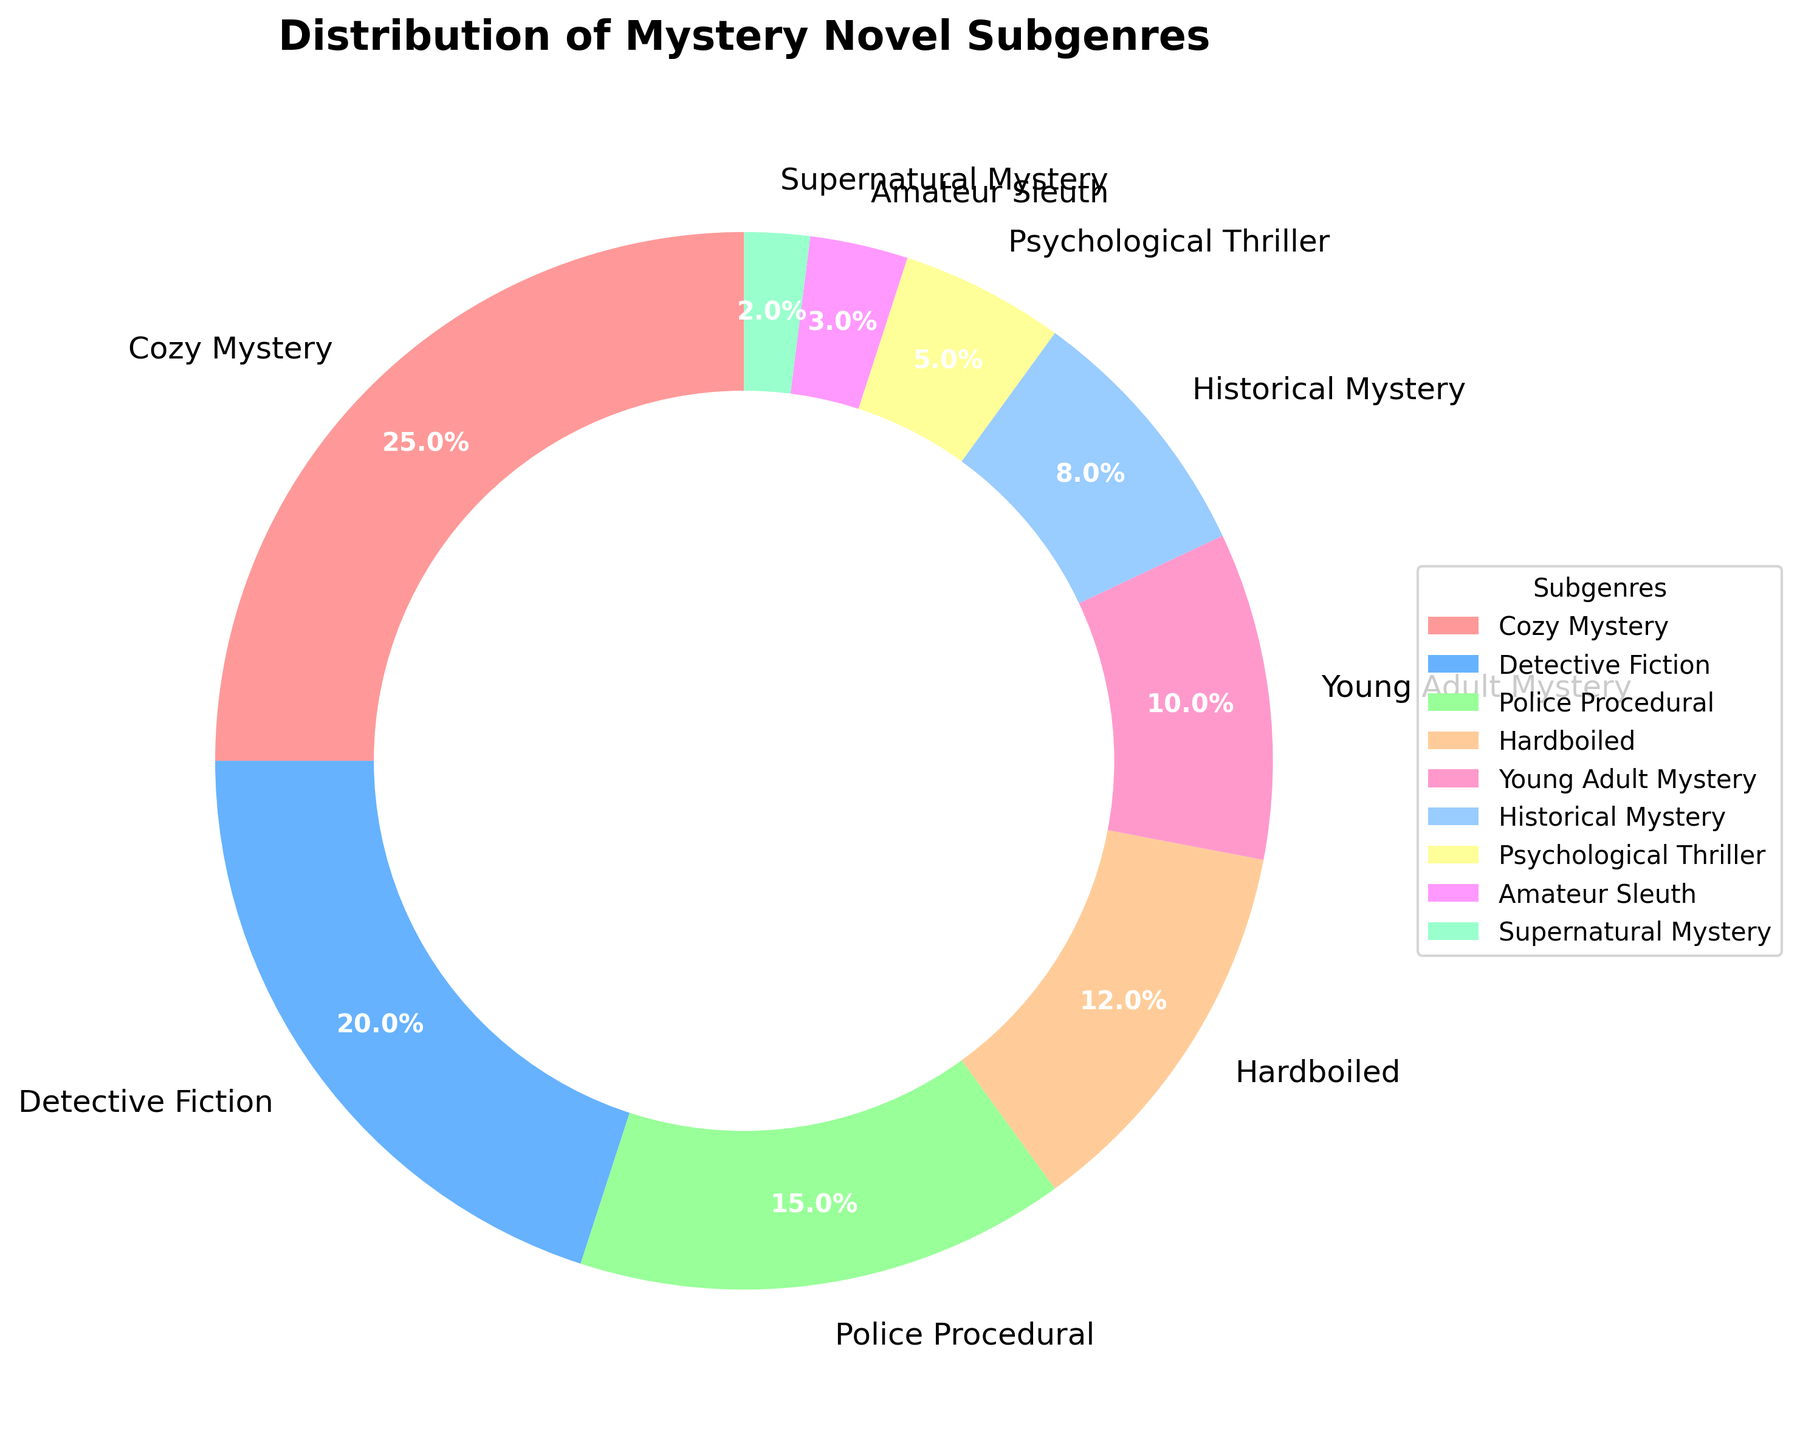Which subgenre occupies the largest portion of the pie chart? The largest portion of the pie chart is represented by the "Cozy Mystery" subgenre, which occupies 25% of the chart.
Answer: Cozy Mystery Which subgenre has the smallest percentage? The smallest portion of the chart is represented by the "Supernatural Mystery" subgenre, which occupies 2% of the chart.
Answer: Supernatural Mystery What is the combined percentage of the "Cozy Mystery" and "Detective Fiction" subgenres? Adding the percentages of "Cozy Mystery" (25%) and "Detective Fiction" (20%) gives us 25% + 20% = 45%.
Answer: 45% How does the percentage of "Police Procedural" subgenre compare to "Hardboiled"? The "Police Procedural" subgenre (15%) has a higher percentage than the "Hardboiled" subgenre, which has 12%.
Answer: Police Procedural > Hardboiled Which two subgenres together make up the smallest percentage? The smallest combined percentage is from the "Supernatural Mystery" (2%) and "Amateur Sleuth" (3%) subgenres, totaling 2% + 3% = 5%.
Answer: Supernatural Mystery and Amateur Sleuth What is the total percentage of subgenres that have a percentage higher than 10%? Identifying subgenres with more than 10%, we have "Cozy Mystery" (25%), "Detective Fiction" (20%), "Police Procedural" (15%), "Hardboiled" (12%), and "Young Adult Mystery" (10%). Adding these percentages gives us 25% + 20% + 15% + 12% + 10% = 82%.
Answer: 82% Which section is colored in blue? The "Detective Fiction" subgenre is colored in blue on the pie chart.
Answer: Detective Fiction If you combine the percentages of "Young Adult Mystery," "Historical Mystery," and "Psychological Thriller," what fraction of the pie chart do they represent? Adding the percentages of "Young Adult Mystery" (10%), "Historical Mystery" (8%), and "Psychological Thriller" (5%) gives 10% + 8% + 5% = 23%. The fraction of the pie chart they represent is 23%.
Answer: 23% Which subgenre has a color that represents caution (often yellow or similar)? The "Historical Mystery" subgenre is represented by a yellow color, symbolizing caution.
Answer: Historical Mystery 